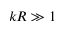<formula> <loc_0><loc_0><loc_500><loc_500>k R \gg 1</formula> 